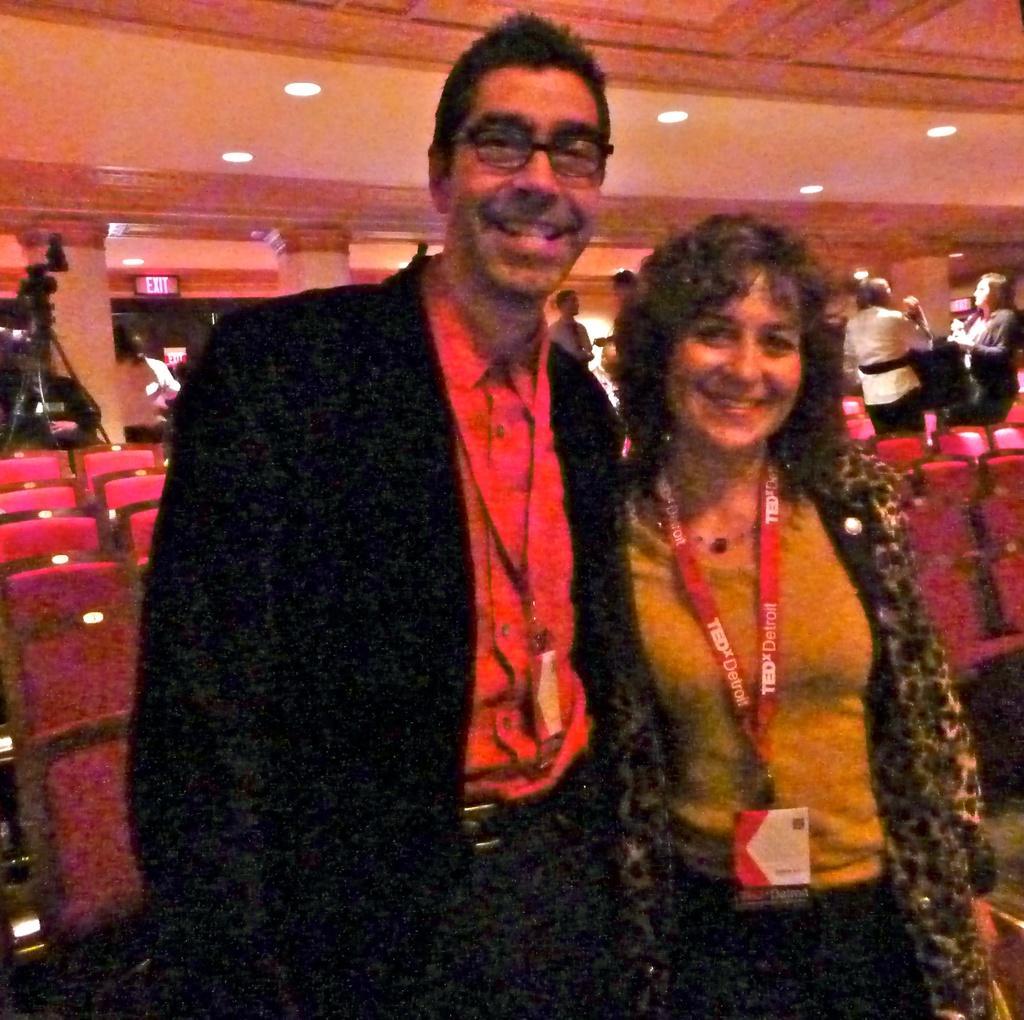In one or two sentences, can you explain what this image depicts? In a conference room there are many empty chairs and in between the chairs there are some people standing and discussing. Behind the chairs in the left side there is a camera and behind the camera there is an exit door. In the front there is a man and a woman,both are posing for the photograph. 